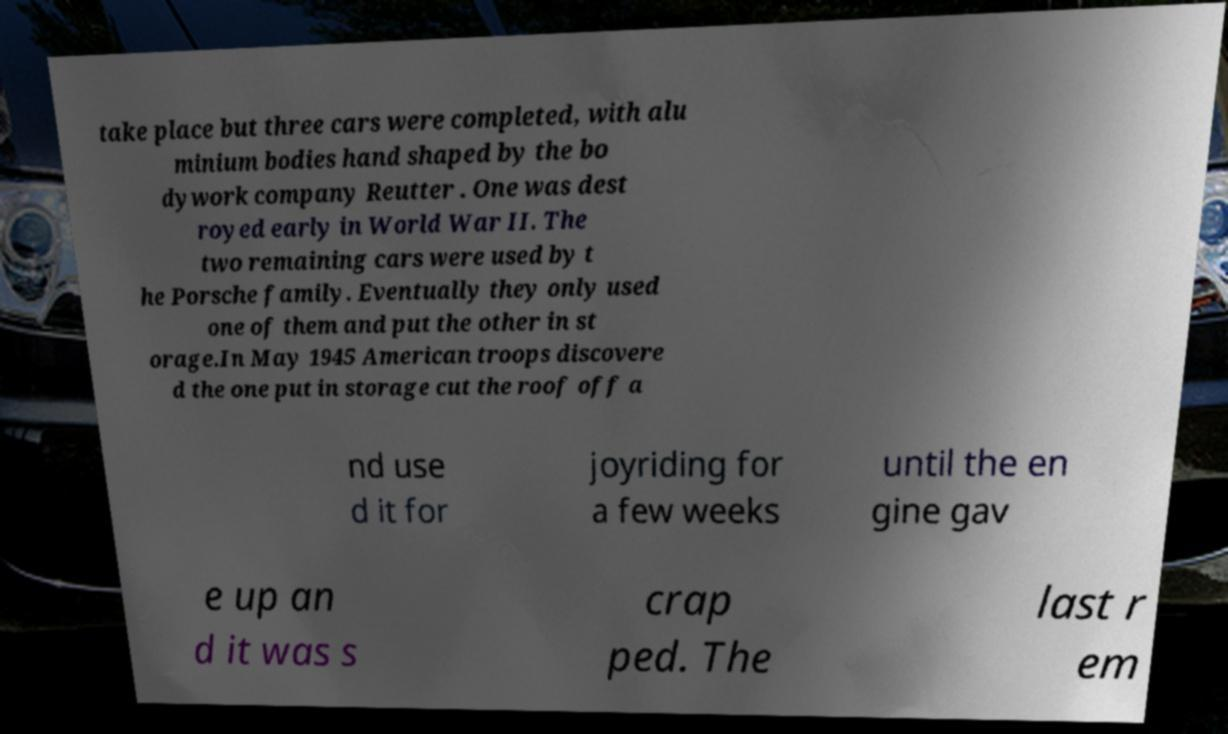I need the written content from this picture converted into text. Can you do that? take place but three cars were completed, with alu minium bodies hand shaped by the bo dywork company Reutter . One was dest royed early in World War II. The two remaining cars were used by t he Porsche family. Eventually they only used one of them and put the other in st orage.In May 1945 American troops discovere d the one put in storage cut the roof off a nd use d it for joyriding for a few weeks until the en gine gav e up an d it was s crap ped. The last r em 